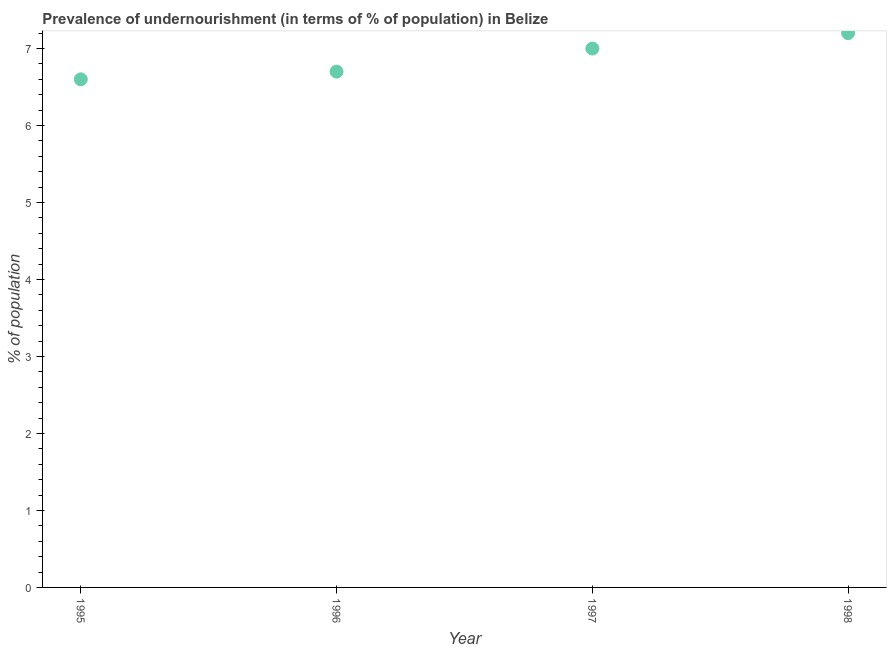Across all years, what is the maximum percentage of undernourished population?
Provide a short and direct response. 7.2. In which year was the percentage of undernourished population minimum?
Make the answer very short. 1995. What is the sum of the percentage of undernourished population?
Your answer should be compact. 27.5. What is the difference between the percentage of undernourished population in 1995 and 1997?
Ensure brevity in your answer.  -0.4. What is the average percentage of undernourished population per year?
Give a very brief answer. 6.88. What is the median percentage of undernourished population?
Offer a very short reply. 6.85. In how many years, is the percentage of undernourished population greater than 0.6000000000000001 %?
Make the answer very short. 4. Do a majority of the years between 1997 and 1995 (inclusive) have percentage of undernourished population greater than 6 %?
Keep it short and to the point. No. What is the ratio of the percentage of undernourished population in 1995 to that in 1996?
Your answer should be compact. 0.99. Is the difference between the percentage of undernourished population in 1996 and 1998 greater than the difference between any two years?
Your answer should be very brief. No. What is the difference between the highest and the second highest percentage of undernourished population?
Ensure brevity in your answer.  0.2. Is the sum of the percentage of undernourished population in 1997 and 1998 greater than the maximum percentage of undernourished population across all years?
Give a very brief answer. Yes. What is the difference between the highest and the lowest percentage of undernourished population?
Ensure brevity in your answer.  0.6. How many years are there in the graph?
Ensure brevity in your answer.  4. Does the graph contain any zero values?
Your answer should be very brief. No. What is the title of the graph?
Provide a succinct answer. Prevalence of undernourishment (in terms of % of population) in Belize. What is the label or title of the Y-axis?
Offer a terse response. % of population. What is the % of population in 1996?
Keep it short and to the point. 6.7. What is the % of population in 1998?
Your answer should be compact. 7.2. What is the difference between the % of population in 1995 and 1996?
Offer a terse response. -0.1. What is the difference between the % of population in 1995 and 1997?
Your answer should be very brief. -0.4. What is the difference between the % of population in 1996 and 1997?
Keep it short and to the point. -0.3. What is the difference between the % of population in 1996 and 1998?
Your response must be concise. -0.5. What is the difference between the % of population in 1997 and 1998?
Provide a succinct answer. -0.2. What is the ratio of the % of population in 1995 to that in 1996?
Make the answer very short. 0.98. What is the ratio of the % of population in 1995 to that in 1997?
Make the answer very short. 0.94. What is the ratio of the % of population in 1995 to that in 1998?
Your answer should be compact. 0.92. What is the ratio of the % of population in 1997 to that in 1998?
Provide a short and direct response. 0.97. 